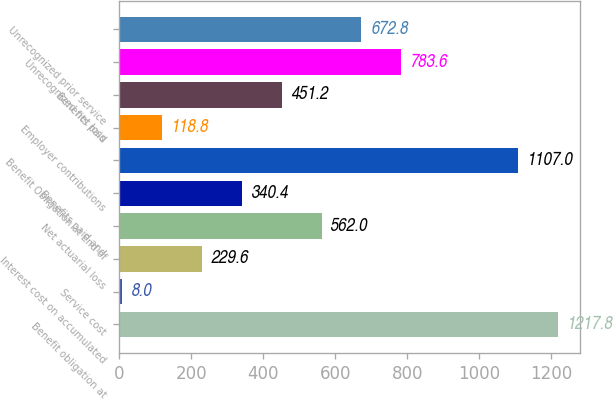Convert chart to OTSL. <chart><loc_0><loc_0><loc_500><loc_500><bar_chart><fcel>Benefit obligation at<fcel>Service cost<fcel>Interest cost on accumulated<fcel>Net actuarial loss<fcel>Benefits paid and<fcel>Benefit Obligation at End of<fcel>Employer contributions<fcel>Benefits paid<fcel>Unrecognized net loss<fcel>Unrecognized prior service<nl><fcel>1217.8<fcel>8<fcel>229.6<fcel>562<fcel>340.4<fcel>1107<fcel>118.8<fcel>451.2<fcel>783.6<fcel>672.8<nl></chart> 